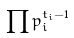<formula> <loc_0><loc_0><loc_500><loc_500>\prod p _ { i } ^ { t _ { i } - 1 }</formula> 